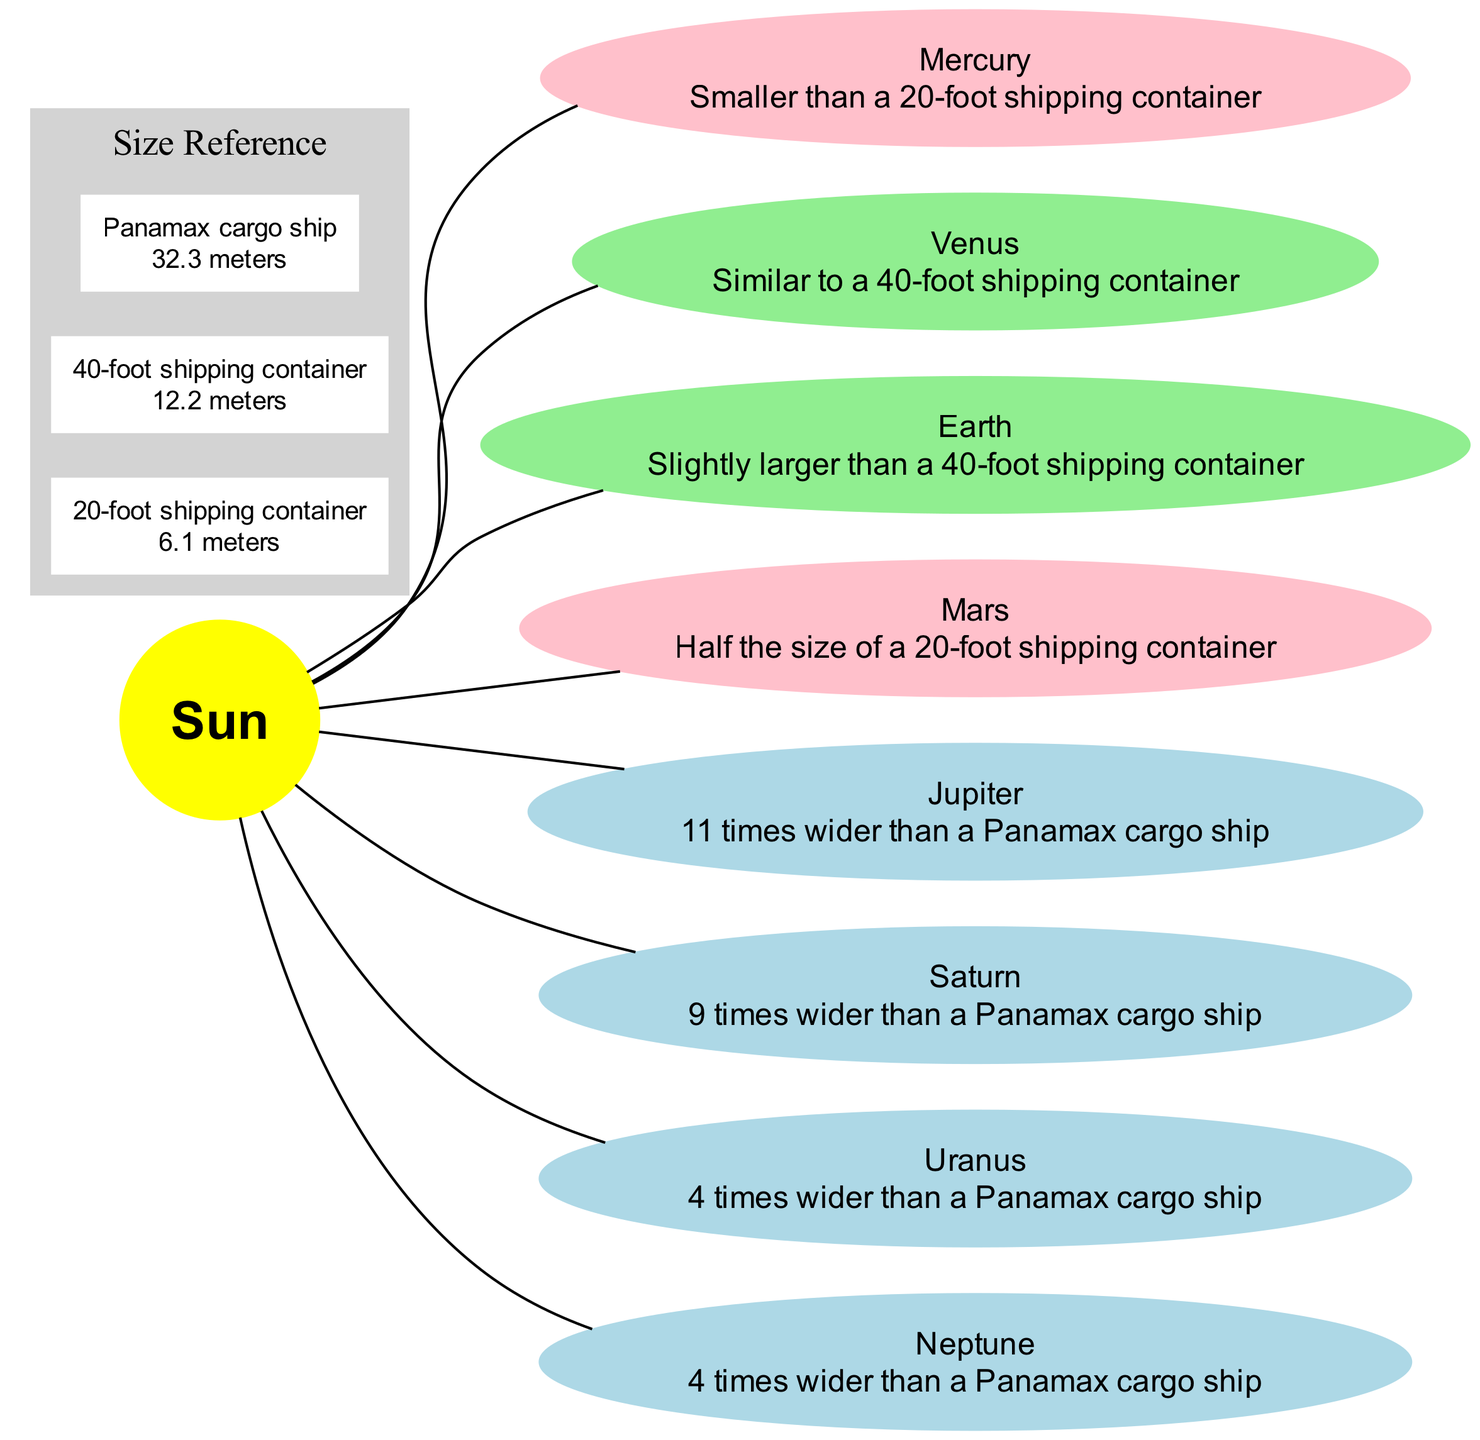What planet is similar in size to a 40-foot shipping container? The diagram indicates that Venus is described as being similar to a 40-foot shipping container. This comparison is directly stated in the size comparison section for Venus.
Answer: Venus How many planets are compared to Panamax cargo ships? Upon reviewing the planets listed in the diagram, Jupiter, Saturn, Uranus, and Neptune are each compared to Panamax cargo ships. This totals four planets.
Answer: 4 What is the size comparison for Earth? The diagram explicitly states that Earth is "Slightly larger than a 40-foot shipping container." This is the size comparison mentioned in the diagram for Earth.
Answer: Slightly larger than a 40-foot shipping container Which planet is the largest based on the size comparisons? By examining the size comparisons, Jupiter is identified as "11 times wider than a Panamax cargo ship," making it the largest planet relative to those described in the diagram. This indicates it has the most significant dimensions compared to the cargo ship reference.
Answer: Jupiter Which planet is smaller than a 20-foot shipping container? The diagram highlights that Mercury is smaller than a 20-foot shipping container. This specific size comparison is clear in the information provided for Mercury.
Answer: Mercury Which planet has a size comparison of "half the size of a 20-foot shipping container"? The diagram states that Mars is half the size of a 20-foot shipping container. This is a direct comparison defined in the diagram for Mars.
Answer: Mars How is Saturn described in the size comparison? The size comparison for Saturn in the diagram is described as "9 times wider than a Panamax cargo ship." This indicates Saturn's size relative to the cargo ship reference.
Answer: 9 times wider than a Panamax cargo ship Which two planets share the same size comparison of being "4 times wider than a Panamax cargo ship"? The diagram clearly indicates that both Uranus and Neptune are described as "4 times wider than a Panamax cargo ship," which shows that they share this size characteristic.
Answer: Uranus, Neptune What is the relative size of Mars compared to typical cargo containers? According to the diagram, Mars is described as "half the size of a 20-foot shipping container." This succinctly summarizes Mars's size relative to a standard shipping container.
Answer: Half the size of a 20-foot shipping container 